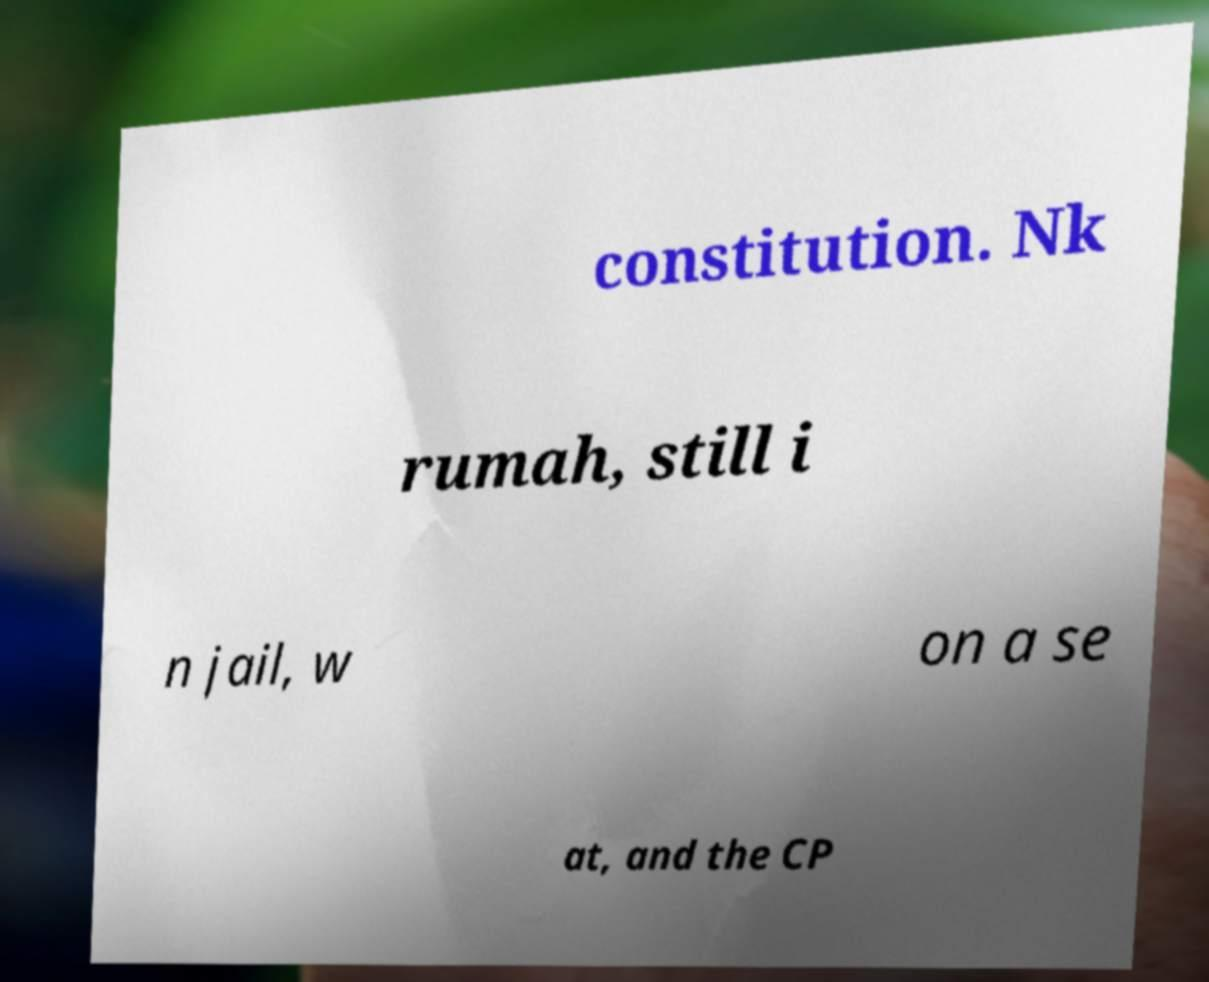For documentation purposes, I need the text within this image transcribed. Could you provide that? constitution. Nk rumah, still i n jail, w on a se at, and the CP 